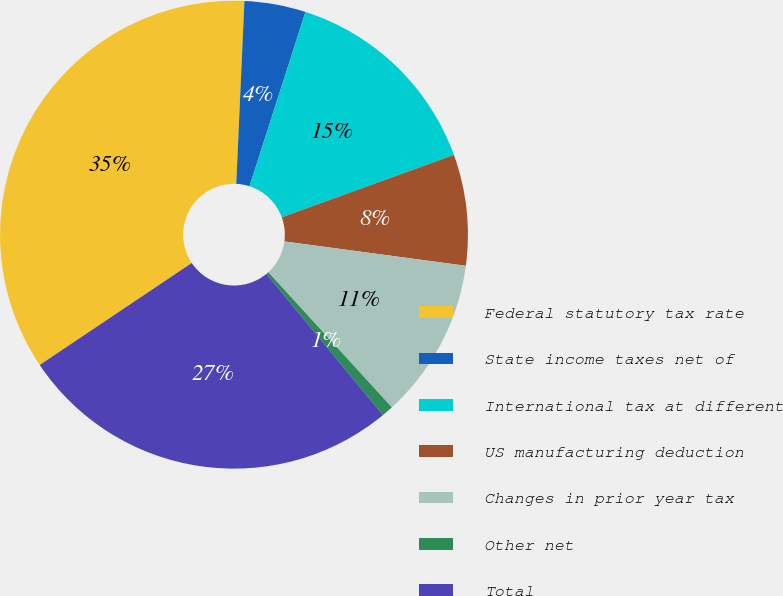<chart> <loc_0><loc_0><loc_500><loc_500><pie_chart><fcel>Federal statutory tax rate<fcel>State income taxes net of<fcel>International tax at different<fcel>US manufacturing deduction<fcel>Changes in prior year tax<fcel>Other net<fcel>Total<nl><fcel>35.11%<fcel>4.23%<fcel>14.52%<fcel>7.66%<fcel>11.09%<fcel>0.8%<fcel>26.58%<nl></chart> 